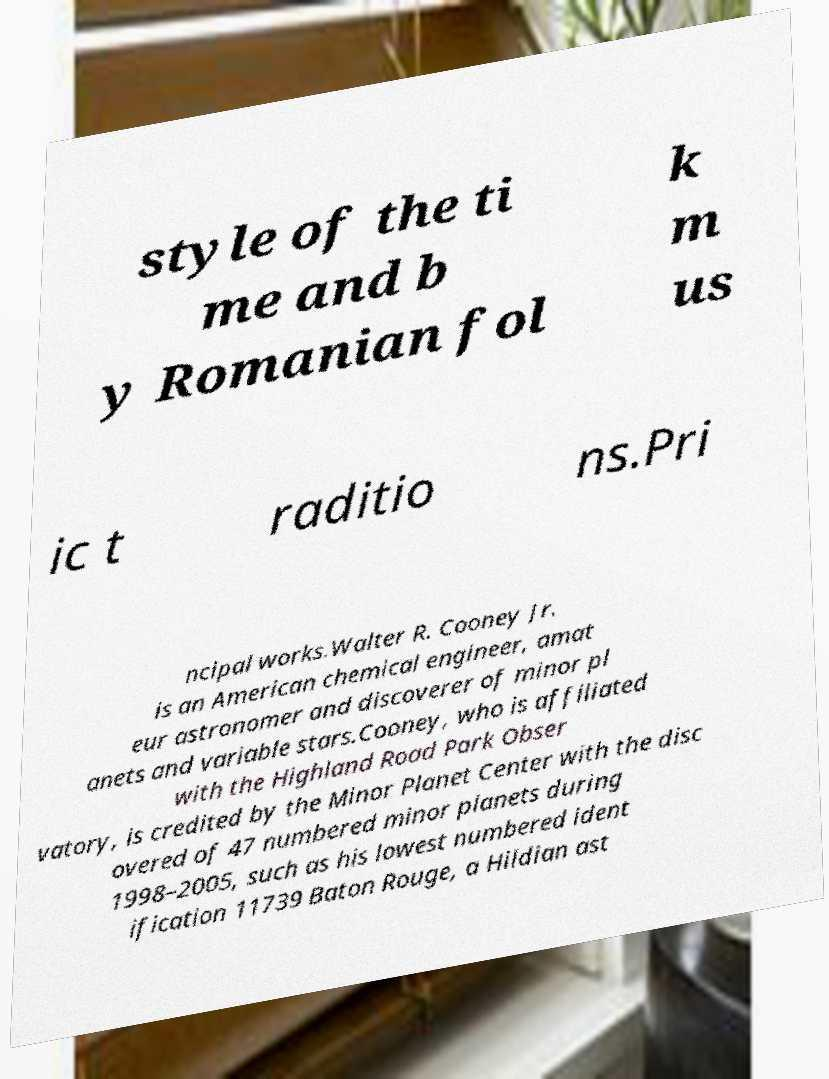There's text embedded in this image that I need extracted. Can you transcribe it verbatim? style of the ti me and b y Romanian fol k m us ic t raditio ns.Pri ncipal works.Walter R. Cooney Jr. is an American chemical engineer, amat eur astronomer and discoverer of minor pl anets and variable stars.Cooney, who is affiliated with the Highland Road Park Obser vatory, is credited by the Minor Planet Center with the disc overed of 47 numbered minor planets during 1998–2005, such as his lowest numbered ident ification 11739 Baton Rouge, a Hildian ast 